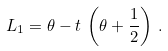<formula> <loc_0><loc_0><loc_500><loc_500>L _ { 1 } = \theta - t \, \left ( \theta + \frac { 1 } { 2 } \right ) \, .</formula> 